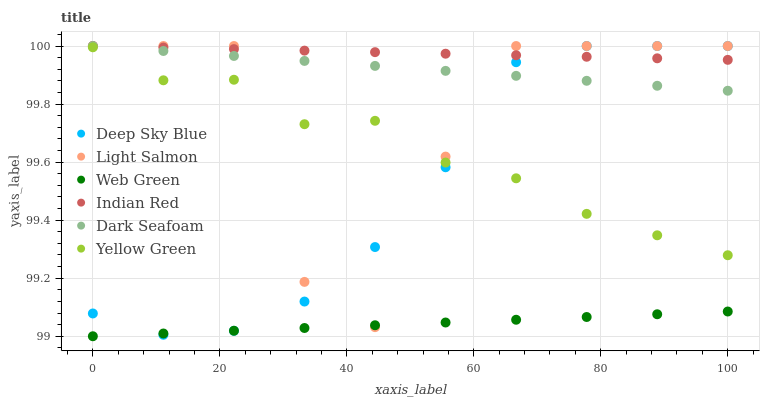Does Web Green have the minimum area under the curve?
Answer yes or no. Yes. Does Indian Red have the maximum area under the curve?
Answer yes or no. Yes. Does Deep Sky Blue have the minimum area under the curve?
Answer yes or no. No. Does Deep Sky Blue have the maximum area under the curve?
Answer yes or no. No. Is Indian Red the smoothest?
Answer yes or no. Yes. Is Light Salmon the roughest?
Answer yes or no. Yes. Is Deep Sky Blue the smoothest?
Answer yes or no. No. Is Deep Sky Blue the roughest?
Answer yes or no. No. Does Web Green have the lowest value?
Answer yes or no. Yes. Does Deep Sky Blue have the lowest value?
Answer yes or no. No. Does Indian Red have the highest value?
Answer yes or no. Yes. Does Web Green have the highest value?
Answer yes or no. No. Is Yellow Green less than Indian Red?
Answer yes or no. Yes. Is Dark Seafoam greater than Yellow Green?
Answer yes or no. Yes. Does Deep Sky Blue intersect Web Green?
Answer yes or no. Yes. Is Deep Sky Blue less than Web Green?
Answer yes or no. No. Is Deep Sky Blue greater than Web Green?
Answer yes or no. No. Does Yellow Green intersect Indian Red?
Answer yes or no. No. 